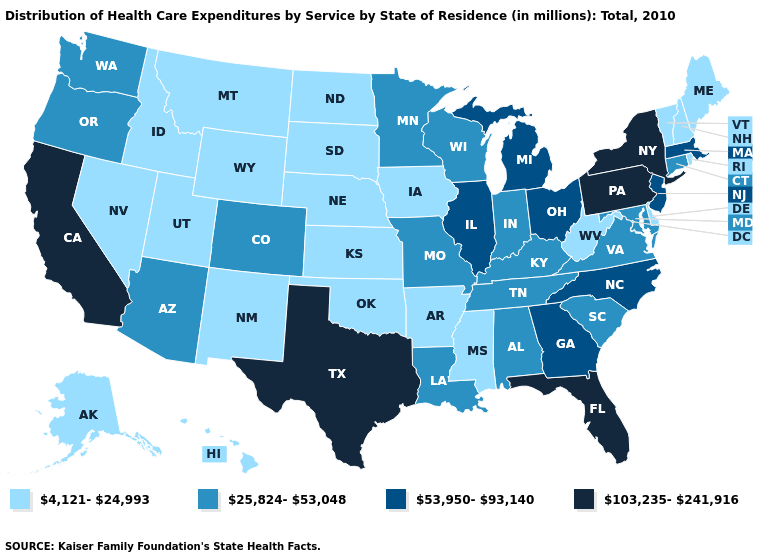Among the states that border Wisconsin , does Iowa have the highest value?
Write a very short answer. No. What is the value of Missouri?
Be succinct. 25,824-53,048. What is the value of Connecticut?
Be succinct. 25,824-53,048. What is the value of Connecticut?
Concise answer only. 25,824-53,048. What is the value of Hawaii?
Keep it brief. 4,121-24,993. What is the value of Pennsylvania?
Keep it brief. 103,235-241,916. Among the states that border Arkansas , which have the lowest value?
Write a very short answer. Mississippi, Oklahoma. Does the first symbol in the legend represent the smallest category?
Give a very brief answer. Yes. Among the states that border Nebraska , which have the lowest value?
Be succinct. Iowa, Kansas, South Dakota, Wyoming. Name the states that have a value in the range 4,121-24,993?
Give a very brief answer. Alaska, Arkansas, Delaware, Hawaii, Idaho, Iowa, Kansas, Maine, Mississippi, Montana, Nebraska, Nevada, New Hampshire, New Mexico, North Dakota, Oklahoma, Rhode Island, South Dakota, Utah, Vermont, West Virginia, Wyoming. What is the value of Massachusetts?
Give a very brief answer. 53,950-93,140. Which states have the highest value in the USA?
Short answer required. California, Florida, New York, Pennsylvania, Texas. Name the states that have a value in the range 53,950-93,140?
Be succinct. Georgia, Illinois, Massachusetts, Michigan, New Jersey, North Carolina, Ohio. Does the first symbol in the legend represent the smallest category?
Quick response, please. Yes. What is the value of Indiana?
Answer briefly. 25,824-53,048. 